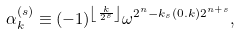<formula> <loc_0><loc_0><loc_500><loc_500>\alpha ^ { ( s ) } _ { k } \equiv ( - 1 ) ^ { \left \lfloor \frac { k } { 2 ^ { s } } \right \rfloor } \omega ^ { 2 ^ { n } - k _ { s } ( 0 . k ) 2 ^ { n + s } } ,</formula> 